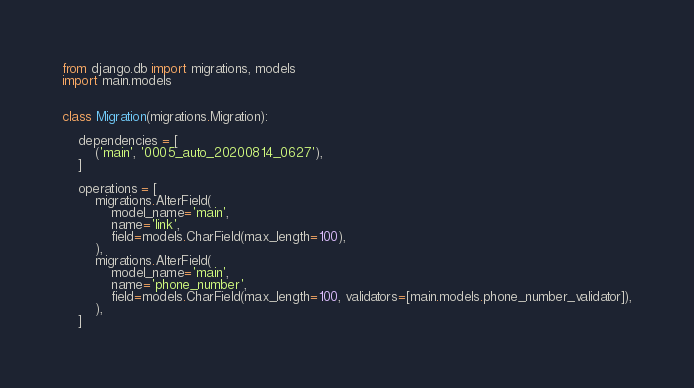Convert code to text. <code><loc_0><loc_0><loc_500><loc_500><_Python_>from django.db import migrations, models
import main.models


class Migration(migrations.Migration):

    dependencies = [
        ('main', '0005_auto_20200814_0627'),
    ]

    operations = [
        migrations.AlterField(
            model_name='main',
            name='link',
            field=models.CharField(max_length=100),
        ),
        migrations.AlterField(
            model_name='main',
            name='phone_number',
            field=models.CharField(max_length=100, validators=[main.models.phone_number_validator]),
        ),
    ]
</code> 